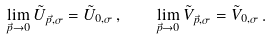<formula> <loc_0><loc_0><loc_500><loc_500>\lim _ { \vec { p } \to 0 } \tilde { U } _ { \vec { p } , \sigma } = \tilde { U } _ { 0 , \sigma } \, , \quad \lim _ { \vec { p } \to 0 } \tilde { V } _ { \vec { p } , \sigma } = \tilde { V } _ { 0 , \sigma } \, .</formula> 